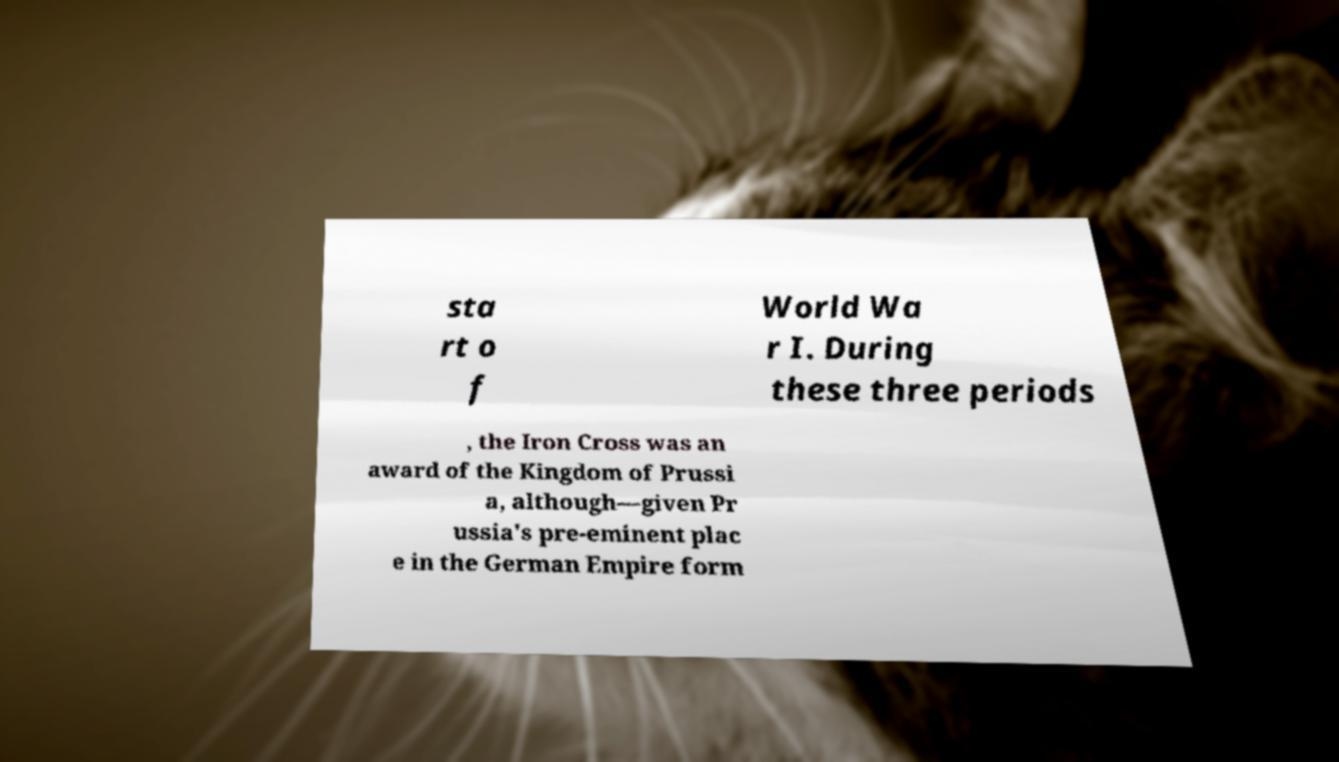Please identify and transcribe the text found in this image. sta rt o f World Wa r I. During these three periods , the Iron Cross was an award of the Kingdom of Prussi a, although—given Pr ussia's pre-eminent plac e in the German Empire form 